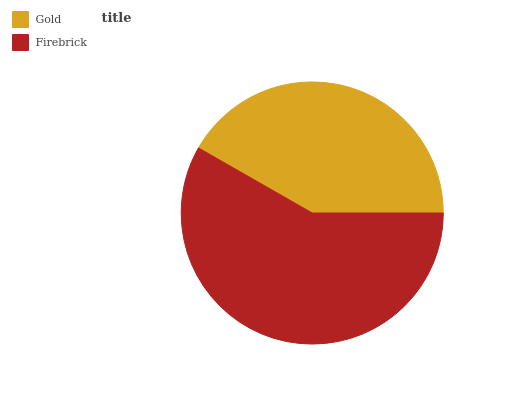Is Gold the minimum?
Answer yes or no. Yes. Is Firebrick the maximum?
Answer yes or no. Yes. Is Firebrick the minimum?
Answer yes or no. No. Is Firebrick greater than Gold?
Answer yes or no. Yes. Is Gold less than Firebrick?
Answer yes or no. Yes. Is Gold greater than Firebrick?
Answer yes or no. No. Is Firebrick less than Gold?
Answer yes or no. No. Is Firebrick the high median?
Answer yes or no. Yes. Is Gold the low median?
Answer yes or no. Yes. Is Gold the high median?
Answer yes or no. No. Is Firebrick the low median?
Answer yes or no. No. 